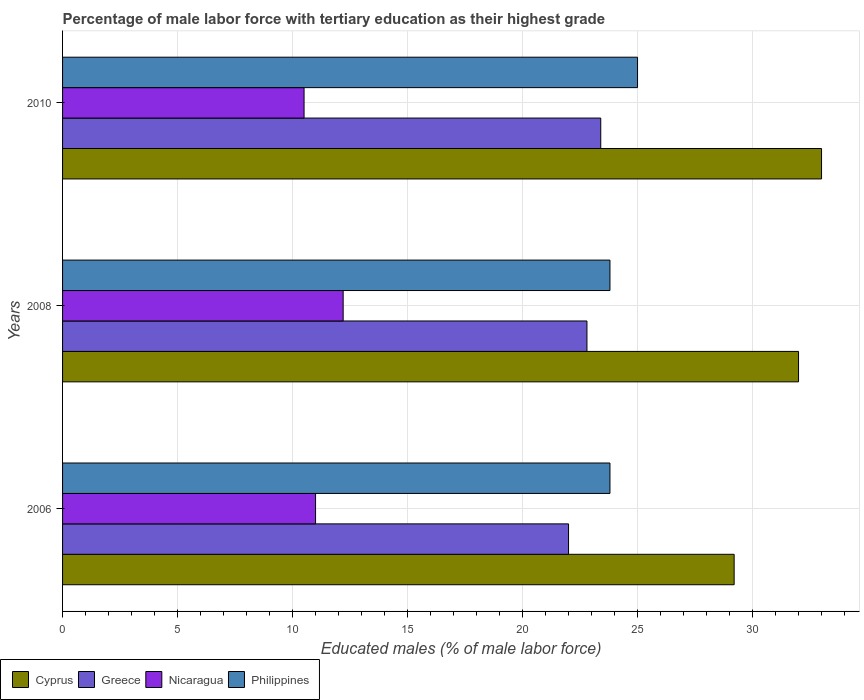Are the number of bars per tick equal to the number of legend labels?
Provide a succinct answer. Yes. How many bars are there on the 3rd tick from the top?
Your answer should be compact. 4. How many bars are there on the 1st tick from the bottom?
Offer a very short reply. 4. Across all years, what is the maximum percentage of male labor force with tertiary education in Greece?
Offer a very short reply. 23.4. Across all years, what is the minimum percentage of male labor force with tertiary education in Cyprus?
Your response must be concise. 29.2. In which year was the percentage of male labor force with tertiary education in Nicaragua minimum?
Your answer should be compact. 2010. What is the total percentage of male labor force with tertiary education in Cyprus in the graph?
Keep it short and to the point. 94.2. What is the difference between the percentage of male labor force with tertiary education in Philippines in 2006 and that in 2010?
Ensure brevity in your answer.  -1.2. What is the average percentage of male labor force with tertiary education in Greece per year?
Ensure brevity in your answer.  22.73. In the year 2006, what is the difference between the percentage of male labor force with tertiary education in Philippines and percentage of male labor force with tertiary education in Cyprus?
Your answer should be very brief. -5.4. What is the ratio of the percentage of male labor force with tertiary education in Philippines in 2006 to that in 2010?
Your answer should be very brief. 0.95. Is the percentage of male labor force with tertiary education in Greece in 2006 less than that in 2008?
Your response must be concise. Yes. What is the difference between the highest and the second highest percentage of male labor force with tertiary education in Philippines?
Provide a short and direct response. 1.2. What is the difference between the highest and the lowest percentage of male labor force with tertiary education in Nicaragua?
Offer a very short reply. 1.7. In how many years, is the percentage of male labor force with tertiary education in Cyprus greater than the average percentage of male labor force with tertiary education in Cyprus taken over all years?
Your response must be concise. 2. Is it the case that in every year, the sum of the percentage of male labor force with tertiary education in Cyprus and percentage of male labor force with tertiary education in Greece is greater than the sum of percentage of male labor force with tertiary education in Philippines and percentage of male labor force with tertiary education in Nicaragua?
Provide a short and direct response. No. What does the 4th bar from the top in 2008 represents?
Ensure brevity in your answer.  Cyprus. What does the 4th bar from the bottom in 2010 represents?
Offer a terse response. Philippines. Is it the case that in every year, the sum of the percentage of male labor force with tertiary education in Philippines and percentage of male labor force with tertiary education in Cyprus is greater than the percentage of male labor force with tertiary education in Nicaragua?
Provide a succinct answer. Yes. Are all the bars in the graph horizontal?
Provide a short and direct response. Yes. Are the values on the major ticks of X-axis written in scientific E-notation?
Offer a terse response. No. Does the graph contain grids?
Offer a terse response. Yes. Where does the legend appear in the graph?
Make the answer very short. Bottom left. How many legend labels are there?
Keep it short and to the point. 4. How are the legend labels stacked?
Keep it short and to the point. Horizontal. What is the title of the graph?
Make the answer very short. Percentage of male labor force with tertiary education as their highest grade. Does "Chad" appear as one of the legend labels in the graph?
Your response must be concise. No. What is the label or title of the X-axis?
Your answer should be very brief. Educated males (% of male labor force). What is the Educated males (% of male labor force) of Cyprus in 2006?
Provide a short and direct response. 29.2. What is the Educated males (% of male labor force) of Greece in 2006?
Your answer should be very brief. 22. What is the Educated males (% of male labor force) of Philippines in 2006?
Make the answer very short. 23.8. What is the Educated males (% of male labor force) of Cyprus in 2008?
Your response must be concise. 32. What is the Educated males (% of male labor force) of Greece in 2008?
Ensure brevity in your answer.  22.8. What is the Educated males (% of male labor force) in Nicaragua in 2008?
Offer a very short reply. 12.2. What is the Educated males (% of male labor force) of Philippines in 2008?
Your answer should be very brief. 23.8. What is the Educated males (% of male labor force) in Greece in 2010?
Your answer should be compact. 23.4. Across all years, what is the maximum Educated males (% of male labor force) in Greece?
Your response must be concise. 23.4. Across all years, what is the maximum Educated males (% of male labor force) in Nicaragua?
Your answer should be very brief. 12.2. Across all years, what is the maximum Educated males (% of male labor force) in Philippines?
Make the answer very short. 25. Across all years, what is the minimum Educated males (% of male labor force) in Cyprus?
Offer a terse response. 29.2. Across all years, what is the minimum Educated males (% of male labor force) of Greece?
Offer a terse response. 22. Across all years, what is the minimum Educated males (% of male labor force) in Nicaragua?
Keep it short and to the point. 10.5. Across all years, what is the minimum Educated males (% of male labor force) of Philippines?
Give a very brief answer. 23.8. What is the total Educated males (% of male labor force) in Cyprus in the graph?
Offer a terse response. 94.2. What is the total Educated males (% of male labor force) of Greece in the graph?
Provide a succinct answer. 68.2. What is the total Educated males (% of male labor force) in Nicaragua in the graph?
Your response must be concise. 33.7. What is the total Educated males (% of male labor force) in Philippines in the graph?
Give a very brief answer. 72.6. What is the difference between the Educated males (% of male labor force) of Cyprus in 2006 and that in 2008?
Provide a short and direct response. -2.8. What is the difference between the Educated males (% of male labor force) in Greece in 2006 and that in 2008?
Give a very brief answer. -0.8. What is the difference between the Educated males (% of male labor force) of Philippines in 2006 and that in 2008?
Your response must be concise. 0. What is the difference between the Educated males (% of male labor force) of Greece in 2006 and that in 2010?
Your response must be concise. -1.4. What is the difference between the Educated males (% of male labor force) in Nicaragua in 2006 and that in 2010?
Offer a terse response. 0.5. What is the difference between the Educated males (% of male labor force) of Cyprus in 2008 and that in 2010?
Give a very brief answer. -1. What is the difference between the Educated males (% of male labor force) of Philippines in 2008 and that in 2010?
Your answer should be compact. -1.2. What is the difference between the Educated males (% of male labor force) of Cyprus in 2006 and the Educated males (% of male labor force) of Nicaragua in 2008?
Keep it short and to the point. 17. What is the difference between the Educated males (% of male labor force) of Cyprus in 2006 and the Educated males (% of male labor force) of Philippines in 2008?
Your answer should be very brief. 5.4. What is the difference between the Educated males (% of male labor force) of Cyprus in 2006 and the Educated males (% of male labor force) of Philippines in 2010?
Provide a short and direct response. 4.2. What is the difference between the Educated males (% of male labor force) of Greece in 2006 and the Educated males (% of male labor force) of Nicaragua in 2010?
Your answer should be compact. 11.5. What is the difference between the Educated males (% of male labor force) in Greece in 2006 and the Educated males (% of male labor force) in Philippines in 2010?
Keep it short and to the point. -3. What is the difference between the Educated males (% of male labor force) in Cyprus in 2008 and the Educated males (% of male labor force) in Nicaragua in 2010?
Give a very brief answer. 21.5. What is the difference between the Educated males (% of male labor force) in Cyprus in 2008 and the Educated males (% of male labor force) in Philippines in 2010?
Your answer should be compact. 7. What is the difference between the Educated males (% of male labor force) of Greece in 2008 and the Educated males (% of male labor force) of Nicaragua in 2010?
Ensure brevity in your answer.  12.3. What is the difference between the Educated males (% of male labor force) in Nicaragua in 2008 and the Educated males (% of male labor force) in Philippines in 2010?
Ensure brevity in your answer.  -12.8. What is the average Educated males (% of male labor force) of Cyprus per year?
Provide a short and direct response. 31.4. What is the average Educated males (% of male labor force) of Greece per year?
Make the answer very short. 22.73. What is the average Educated males (% of male labor force) of Nicaragua per year?
Provide a succinct answer. 11.23. What is the average Educated males (% of male labor force) of Philippines per year?
Provide a short and direct response. 24.2. In the year 2006, what is the difference between the Educated males (% of male labor force) in Cyprus and Educated males (% of male labor force) in Greece?
Ensure brevity in your answer.  7.2. In the year 2006, what is the difference between the Educated males (% of male labor force) of Cyprus and Educated males (% of male labor force) of Nicaragua?
Make the answer very short. 18.2. In the year 2006, what is the difference between the Educated males (% of male labor force) of Greece and Educated males (% of male labor force) of Nicaragua?
Keep it short and to the point. 11. In the year 2006, what is the difference between the Educated males (% of male labor force) of Nicaragua and Educated males (% of male labor force) of Philippines?
Give a very brief answer. -12.8. In the year 2008, what is the difference between the Educated males (% of male labor force) in Cyprus and Educated males (% of male labor force) in Greece?
Provide a succinct answer. 9.2. In the year 2008, what is the difference between the Educated males (% of male labor force) of Cyprus and Educated males (% of male labor force) of Nicaragua?
Your response must be concise. 19.8. In the year 2008, what is the difference between the Educated males (% of male labor force) in Greece and Educated males (% of male labor force) in Nicaragua?
Ensure brevity in your answer.  10.6. In the year 2010, what is the difference between the Educated males (% of male labor force) in Cyprus and Educated males (% of male labor force) in Nicaragua?
Provide a short and direct response. 22.5. In the year 2010, what is the difference between the Educated males (% of male labor force) in Greece and Educated males (% of male labor force) in Philippines?
Make the answer very short. -1.6. In the year 2010, what is the difference between the Educated males (% of male labor force) of Nicaragua and Educated males (% of male labor force) of Philippines?
Provide a succinct answer. -14.5. What is the ratio of the Educated males (% of male labor force) in Cyprus in 2006 to that in 2008?
Your answer should be very brief. 0.91. What is the ratio of the Educated males (% of male labor force) in Greece in 2006 to that in 2008?
Give a very brief answer. 0.96. What is the ratio of the Educated males (% of male labor force) in Nicaragua in 2006 to that in 2008?
Ensure brevity in your answer.  0.9. What is the ratio of the Educated males (% of male labor force) in Cyprus in 2006 to that in 2010?
Your answer should be very brief. 0.88. What is the ratio of the Educated males (% of male labor force) of Greece in 2006 to that in 2010?
Your answer should be very brief. 0.94. What is the ratio of the Educated males (% of male labor force) of Nicaragua in 2006 to that in 2010?
Make the answer very short. 1.05. What is the ratio of the Educated males (% of male labor force) of Cyprus in 2008 to that in 2010?
Offer a very short reply. 0.97. What is the ratio of the Educated males (% of male labor force) of Greece in 2008 to that in 2010?
Offer a very short reply. 0.97. What is the ratio of the Educated males (% of male labor force) of Nicaragua in 2008 to that in 2010?
Ensure brevity in your answer.  1.16. What is the difference between the highest and the second highest Educated males (% of male labor force) in Cyprus?
Make the answer very short. 1. What is the difference between the highest and the lowest Educated males (% of male labor force) in Cyprus?
Offer a terse response. 3.8. 